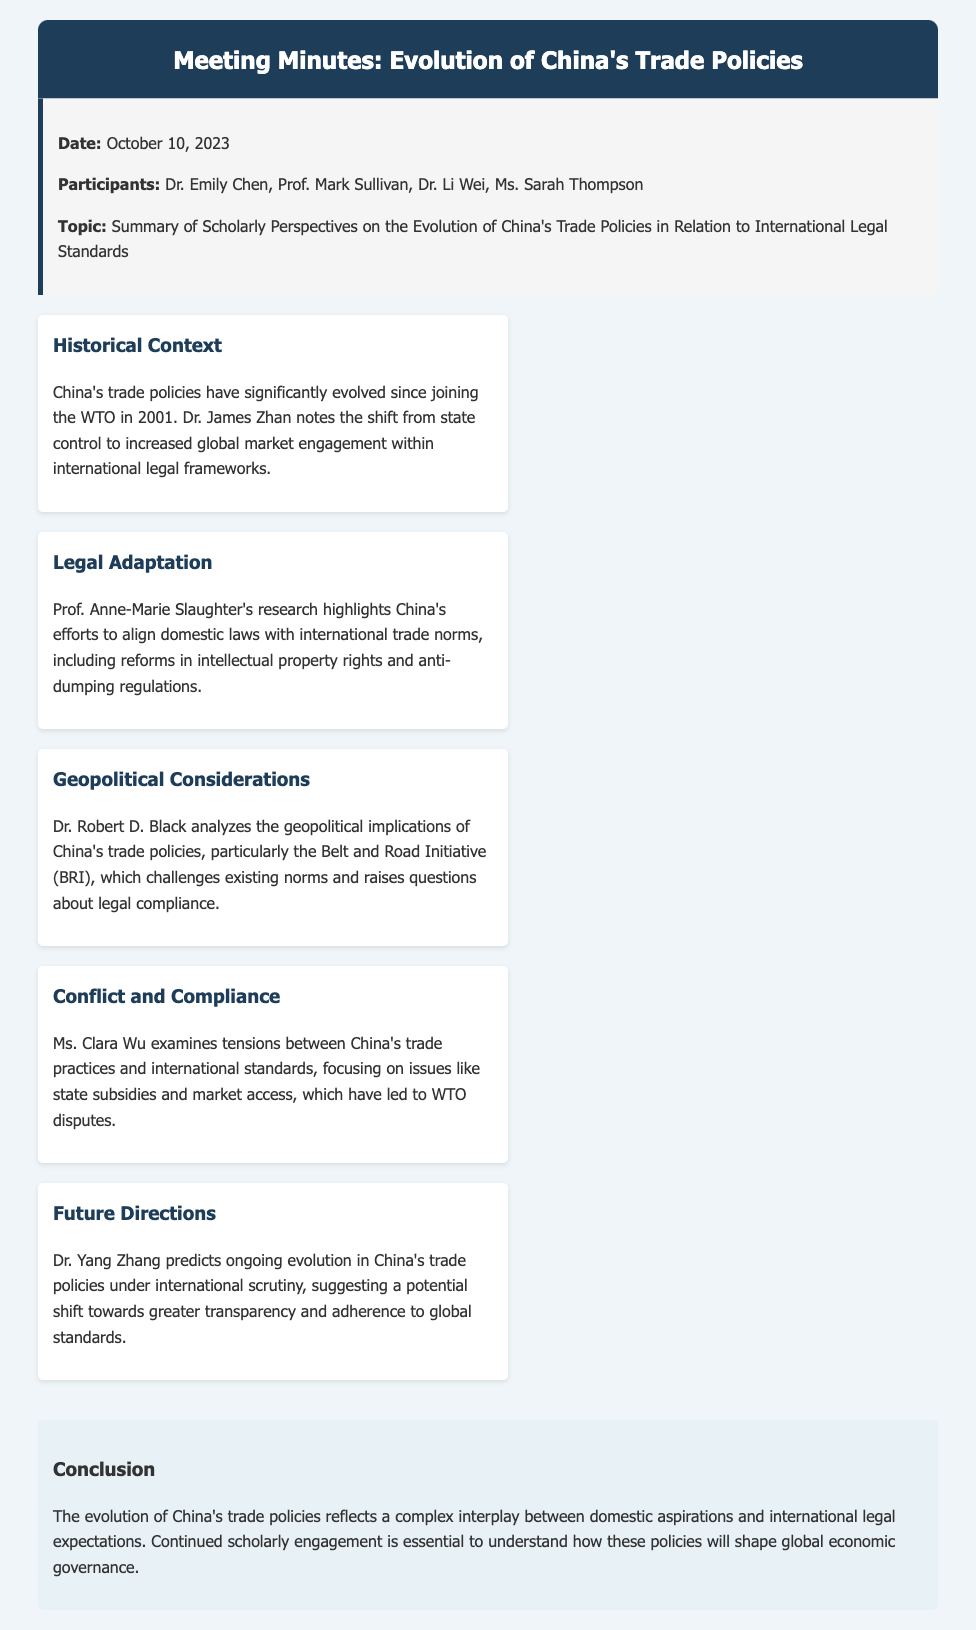What date was the meeting held? The document states that the meeting took place on October 10, 2023.
Answer: October 10, 2023 Who noted the shift from state control to increased global market engagement? Dr. James Zhan is credited with this observation in the historical context section.
Answer: Dr. James Zhan What initiative is analyzed for its geopolitical implications? The Belt and Road Initiative (BRI) is mentioned as a significant factor in geopolitical considerations.
Answer: Belt and Road Initiative (BRI) Which area of law does Prof. Anne-Marie Slaughter's research focus on? Her research highlights reforms in intellectual property rights and anti-dumping regulations related to international trade norms.
Answer: Intellectual property rights and anti-dumping regulations What does Dr. Yang Zhang predict for the future of China's trade policies? He suggests a potential shift towards greater transparency and adherence to global standards.
Answer: Greater transparency and adherence to global standards What is the main conclusion drawn from the meeting minutes? The conclusion reflects on the complex interplay between domestic aspirations and international legal expectations regarding China's trade policies.
Answer: Complex interplay between domestic aspirations and international legal expectations How many participants were there in the meeting? The document lists four participants who attended the meeting.
Answer: Four What aspect of China's trade practices is examined by Ms. Clara Wu? Ms. Clara Wu examines tensions between China's trade practices and international standards.
Answer: Tensions between China's trade practices and international standards 